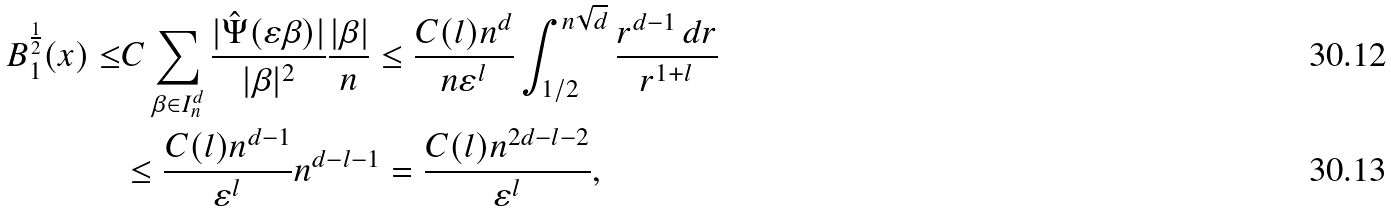<formula> <loc_0><loc_0><loc_500><loc_500>B _ { 1 } ^ { \frac { 1 } { 2 } } ( x ) \leq & C \sum _ { \beta \in I ^ { d } _ { n } } \frac { | \hat { \Psi } ( \varepsilon \beta ) | } { | \beta | ^ { 2 } } \frac { | \beta | } { n } \leq \frac { C ( l ) n ^ { d } } { n \varepsilon ^ { l } } \int _ { 1 / 2 } ^ { n \sqrt { d } } \frac { r ^ { d - 1 } \, d r } { r ^ { 1 + l } } \\ & \leq \frac { C ( l ) n ^ { d - 1 } } { \varepsilon ^ { l } } n ^ { d - l - 1 } = \frac { C ( l ) n ^ { 2 d - l - 2 } } { \varepsilon ^ { l } } ,</formula> 